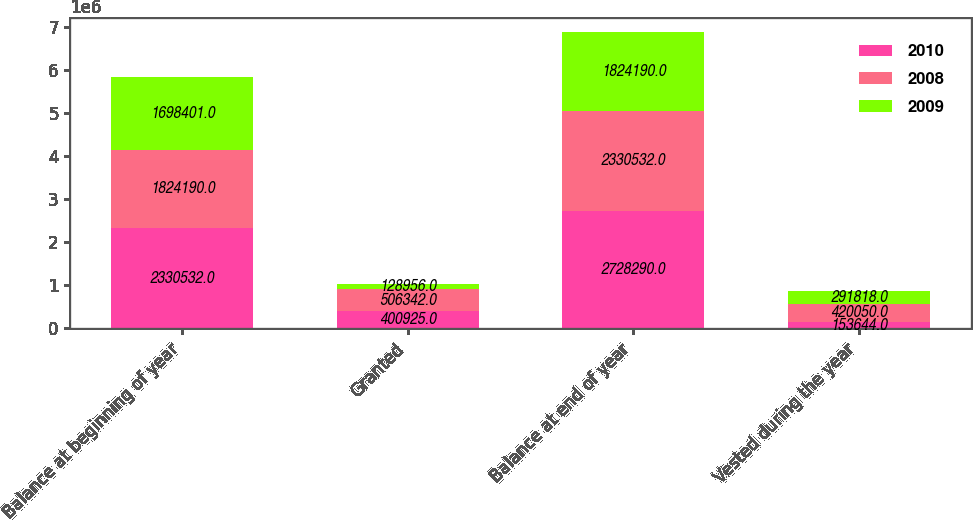Convert chart to OTSL. <chart><loc_0><loc_0><loc_500><loc_500><stacked_bar_chart><ecel><fcel>Balance at beginning of year<fcel>Granted<fcel>Balance at end of year<fcel>Vested during the year<nl><fcel>2010<fcel>2.33053e+06<fcel>400925<fcel>2.72829e+06<fcel>153644<nl><fcel>2008<fcel>1.82419e+06<fcel>506342<fcel>2.33053e+06<fcel>420050<nl><fcel>2009<fcel>1.6984e+06<fcel>128956<fcel>1.82419e+06<fcel>291818<nl></chart> 